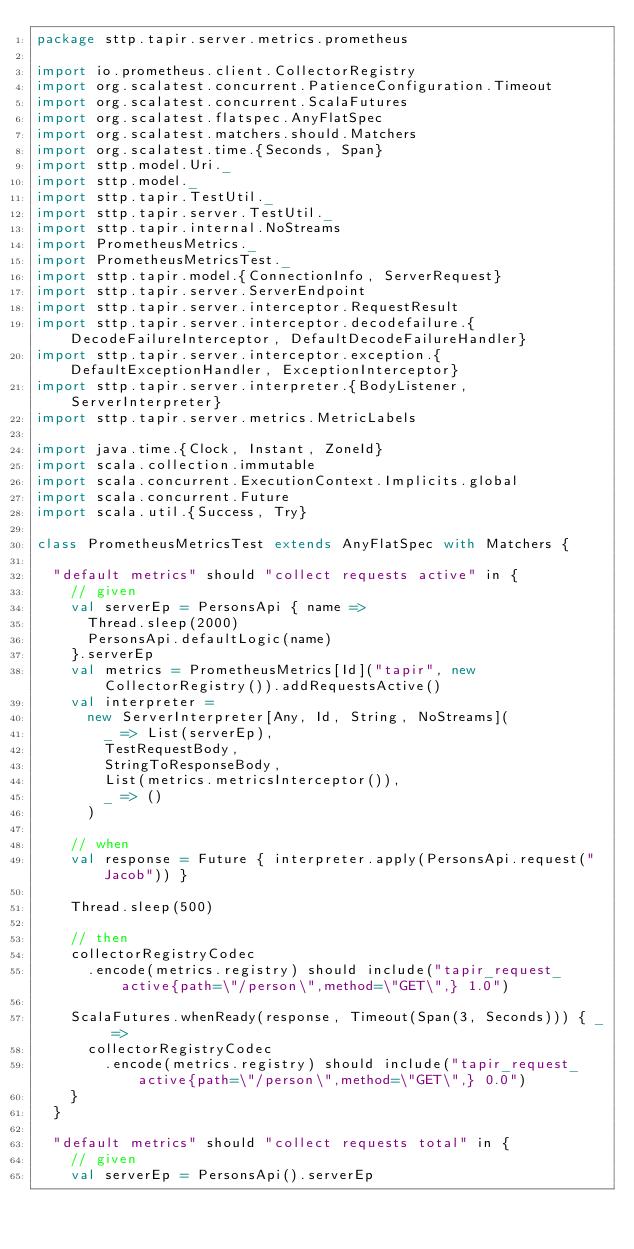Convert code to text. <code><loc_0><loc_0><loc_500><loc_500><_Scala_>package sttp.tapir.server.metrics.prometheus

import io.prometheus.client.CollectorRegistry
import org.scalatest.concurrent.PatienceConfiguration.Timeout
import org.scalatest.concurrent.ScalaFutures
import org.scalatest.flatspec.AnyFlatSpec
import org.scalatest.matchers.should.Matchers
import org.scalatest.time.{Seconds, Span}
import sttp.model.Uri._
import sttp.model._
import sttp.tapir.TestUtil._
import sttp.tapir.server.TestUtil._
import sttp.tapir.internal.NoStreams
import PrometheusMetrics._
import PrometheusMetricsTest._
import sttp.tapir.model.{ConnectionInfo, ServerRequest}
import sttp.tapir.server.ServerEndpoint
import sttp.tapir.server.interceptor.RequestResult
import sttp.tapir.server.interceptor.decodefailure.{DecodeFailureInterceptor, DefaultDecodeFailureHandler}
import sttp.tapir.server.interceptor.exception.{DefaultExceptionHandler, ExceptionInterceptor}
import sttp.tapir.server.interpreter.{BodyListener, ServerInterpreter}
import sttp.tapir.server.metrics.MetricLabels

import java.time.{Clock, Instant, ZoneId}
import scala.collection.immutable
import scala.concurrent.ExecutionContext.Implicits.global
import scala.concurrent.Future
import scala.util.{Success, Try}

class PrometheusMetricsTest extends AnyFlatSpec with Matchers {

  "default metrics" should "collect requests active" in {
    // given
    val serverEp = PersonsApi { name =>
      Thread.sleep(2000)
      PersonsApi.defaultLogic(name)
    }.serverEp
    val metrics = PrometheusMetrics[Id]("tapir", new CollectorRegistry()).addRequestsActive()
    val interpreter =
      new ServerInterpreter[Any, Id, String, NoStreams](
        _ => List(serverEp),
        TestRequestBody,
        StringToResponseBody,
        List(metrics.metricsInterceptor()),
        _ => ()
      )

    // when
    val response = Future { interpreter.apply(PersonsApi.request("Jacob")) }

    Thread.sleep(500)

    // then
    collectorRegistryCodec
      .encode(metrics.registry) should include("tapir_request_active{path=\"/person\",method=\"GET\",} 1.0")

    ScalaFutures.whenReady(response, Timeout(Span(3, Seconds))) { _ =>
      collectorRegistryCodec
        .encode(metrics.registry) should include("tapir_request_active{path=\"/person\",method=\"GET\",} 0.0")
    }
  }

  "default metrics" should "collect requests total" in {
    // given
    val serverEp = PersonsApi().serverEp</code> 